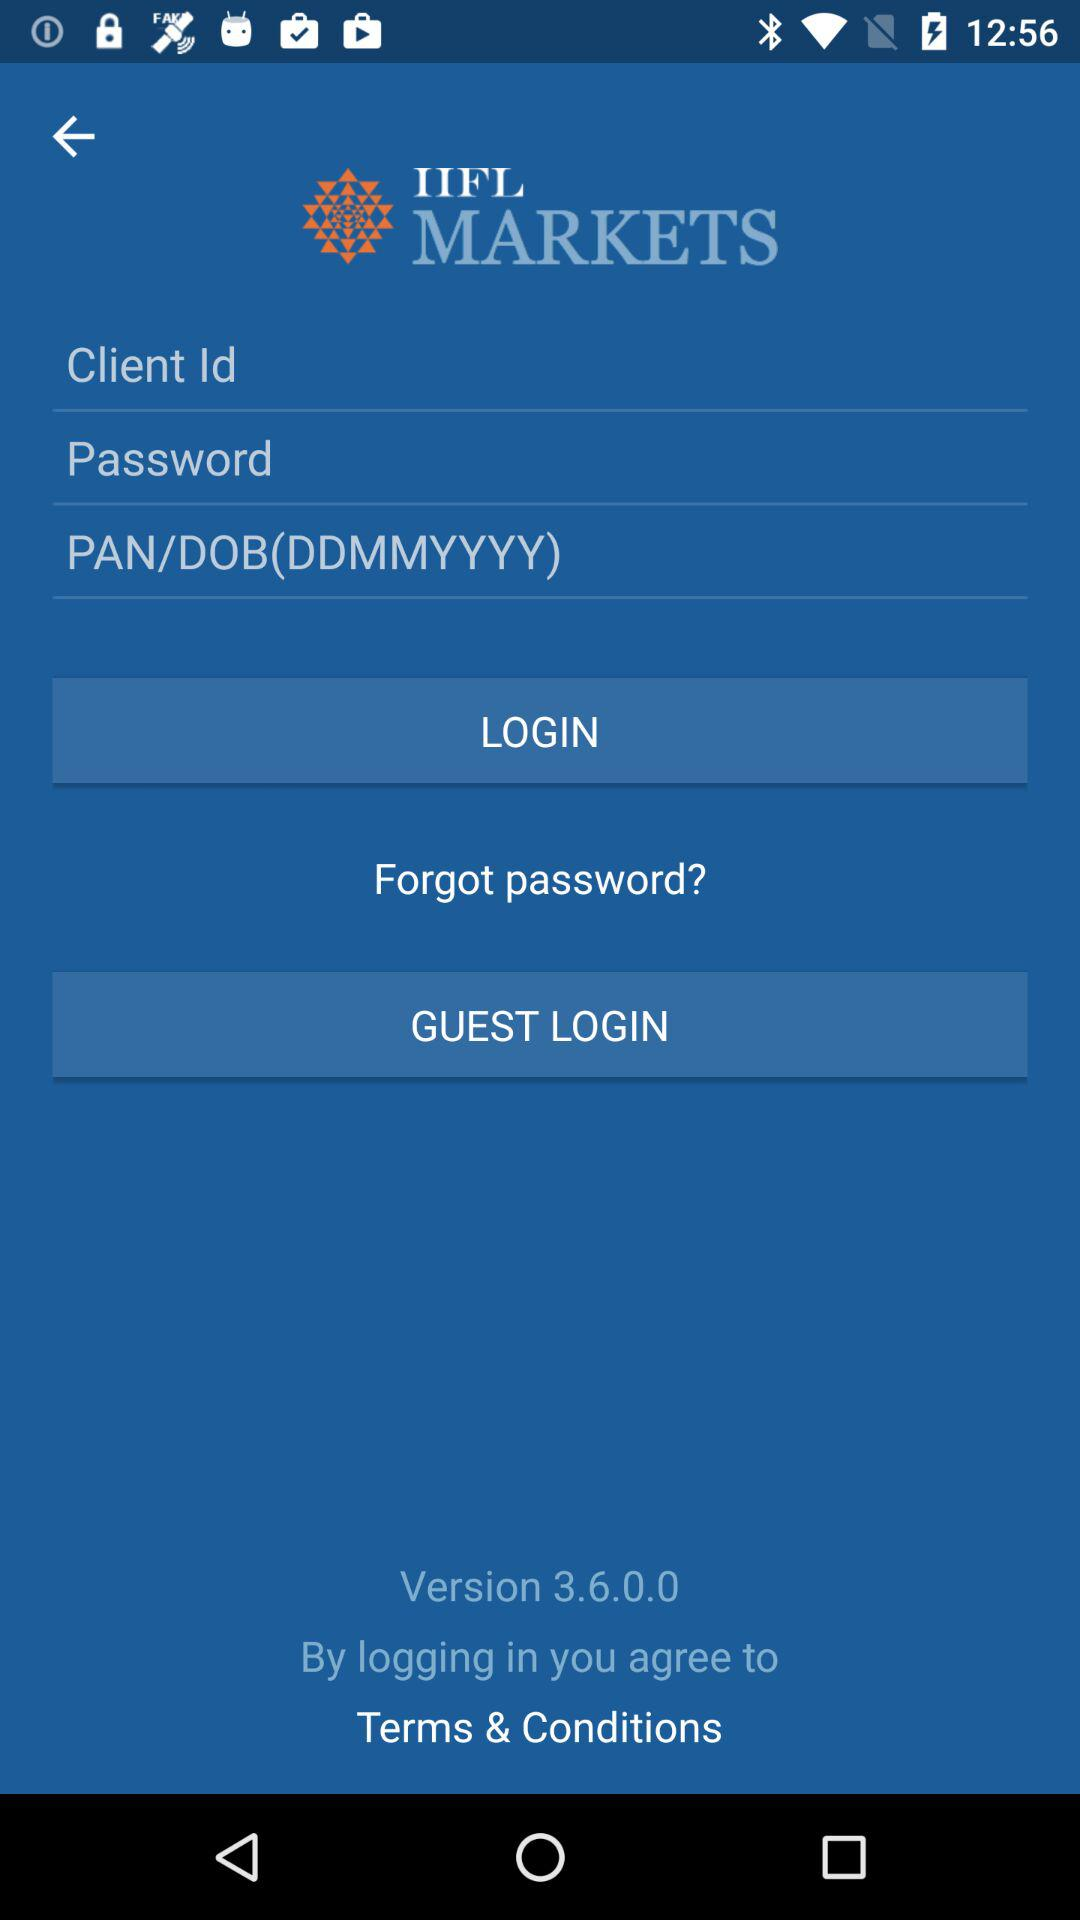What is the application name? The application name is "IIFL MARKETS". 